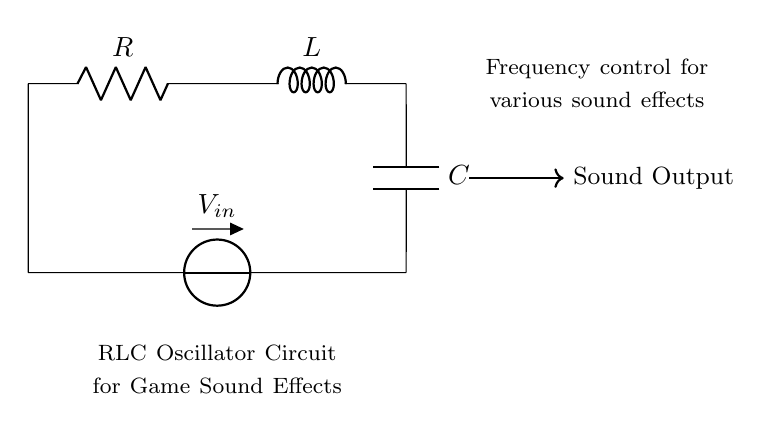What components are in the circuit? The circuit contains a resistor, an inductor, and a capacitor. These are standard components in an RLC circuit that interact to create oscillating signals.
Answer: Resistor, Inductor, Capacitor What is the purpose of the circuit? The circuit is designed to generate sound effects for a game. The interaction of the resistor, inductor, and capacitor creates oscillations that can be used to produce sound frequencies.
Answer: Generate sound effects How does the inductor affect the oscillator? The inductor stores energy in a magnetic field when current flows through it and influences the timing of oscillations within the circuit. It plays a crucial role in determining the frequency of the output.
Answer: Affects frequency What does the voltage source provide? The voltage source, denoted as V in the circuit, supplies the energy necessary to maintain oscillations in the circuit. Without this source, the circuit would not function to produce sound.
Answer: Energy supply How do resistance and capacitance affect the oscillation frequency? The resistance influences the damping of the oscillations, while the capacitance determines the rate at which the capacitor charges and discharges, both factors together influence the overall frequency of oscillations in the circuit.
Answer: Affect oscillation frequency What is the type of connection between the components? The components are connected in series; the current flows sequentially through each one leading to a combined effect on the circuit's behavior as it operates.
Answer: Series connection What type of oscillation does the RLC circuit produce? The RLC circuit produces damped oscillations when energy is dissipated by the resistor. This leads to a gradual decrease in amplitude over time, which can be useful for creating sound effects.
Answer: Damped oscillations 